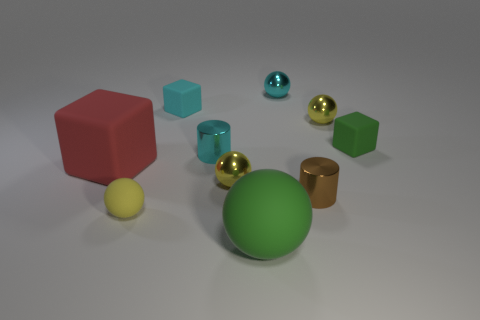Is there a pattern to the arrangement of the objects? While there is no strict pattern to the arrangement of objects, they are placed in a somewhat diagonal line that starts from the bottom left with the large red cube and ends on the top right with the small green cube. This could suggest an intentional composition designed to guide the viewer's eye through the image. 